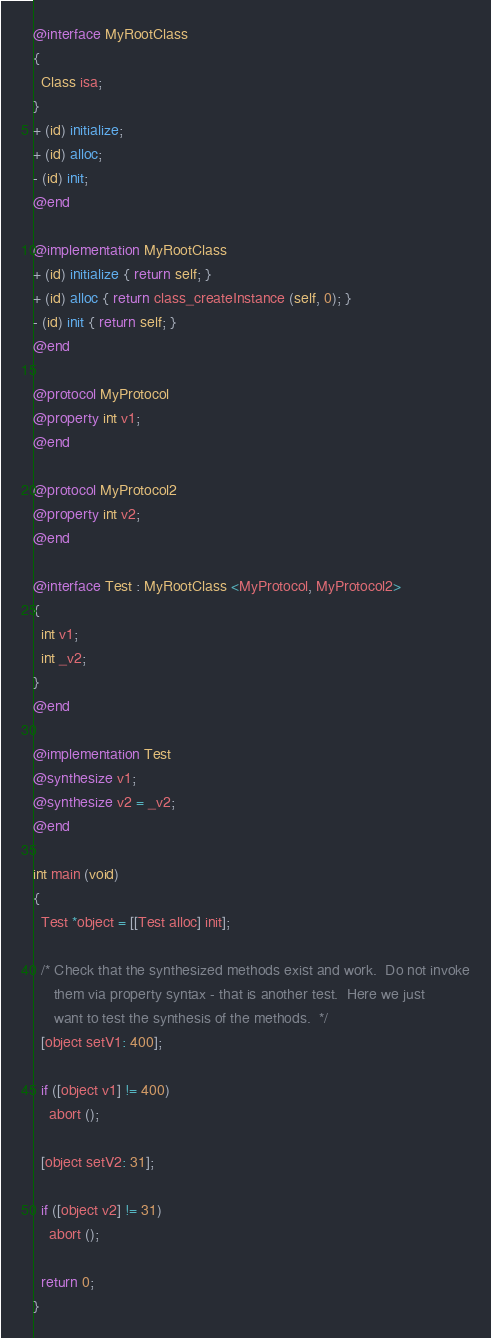Convert code to text. <code><loc_0><loc_0><loc_500><loc_500><_ObjectiveC_>@interface MyRootClass
{
  Class isa;
}
+ (id) initialize;
+ (id) alloc;
- (id) init;
@end

@implementation MyRootClass
+ (id) initialize { return self; }
+ (id) alloc { return class_createInstance (self, 0); }
- (id) init { return self; }
@end

@protocol MyProtocol
@property int v1;
@end

@protocol MyProtocol2
@property int v2;
@end

@interface Test : MyRootClass <MyProtocol, MyProtocol2>
{
  int v1;
  int _v2;
}
@end

@implementation Test
@synthesize v1;
@synthesize v2 = _v2;
@end

int main (void)
{
  Test *object = [[Test alloc] init];

  /* Check that the synthesized methods exist and work.  Do not invoke
     them via property syntax - that is another test.  Here we just
     want to test the synthesis of the methods.  */
  [object setV1: 400];

  if ([object v1] != 400)
    abort ();

  [object setV2: 31];

  if ([object v2] != 31)
    abort ();

  return 0;
}
</code> 